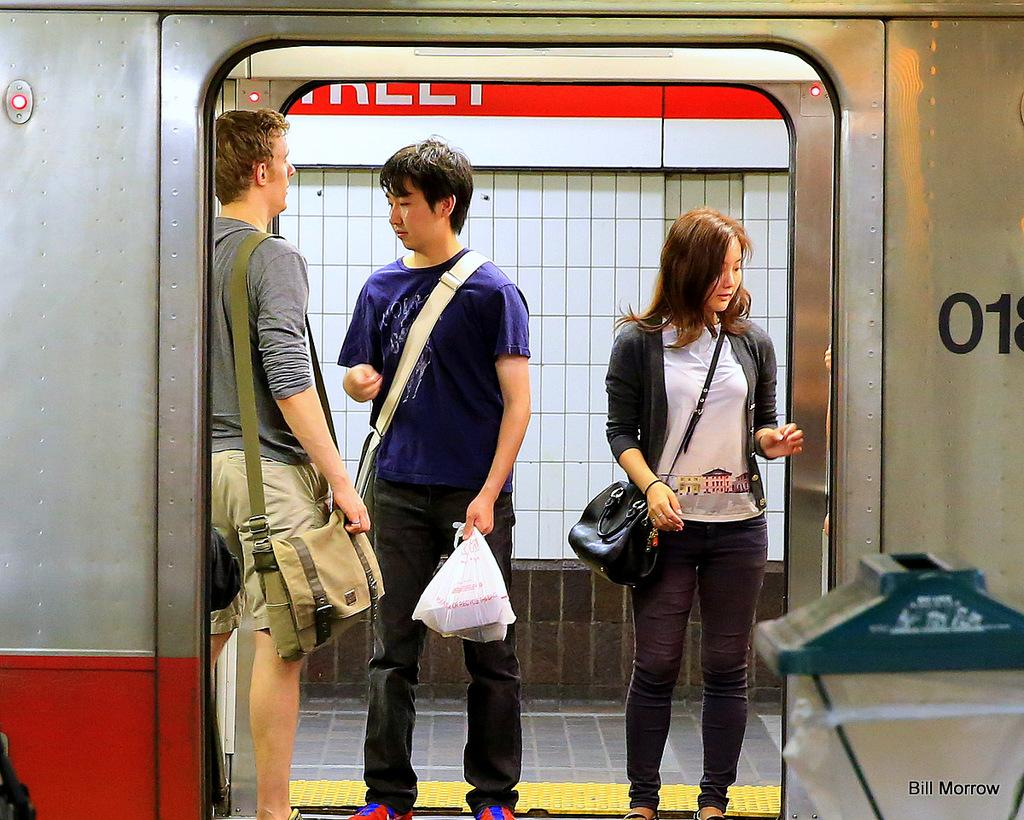What are the people in the image doing? The people in the image are standing in the middle of the image. What are the people holding in their hands? The people are holding something in their hands. What can be seen in the background of the image? There is a fence and a white wall in the background of the image. Are there any fairies flying around the people in the image? No, there are no fairies present in the image. Can you see any bikes or bicycles in the image? No, there are no bikes or bicycles visible in the image. 